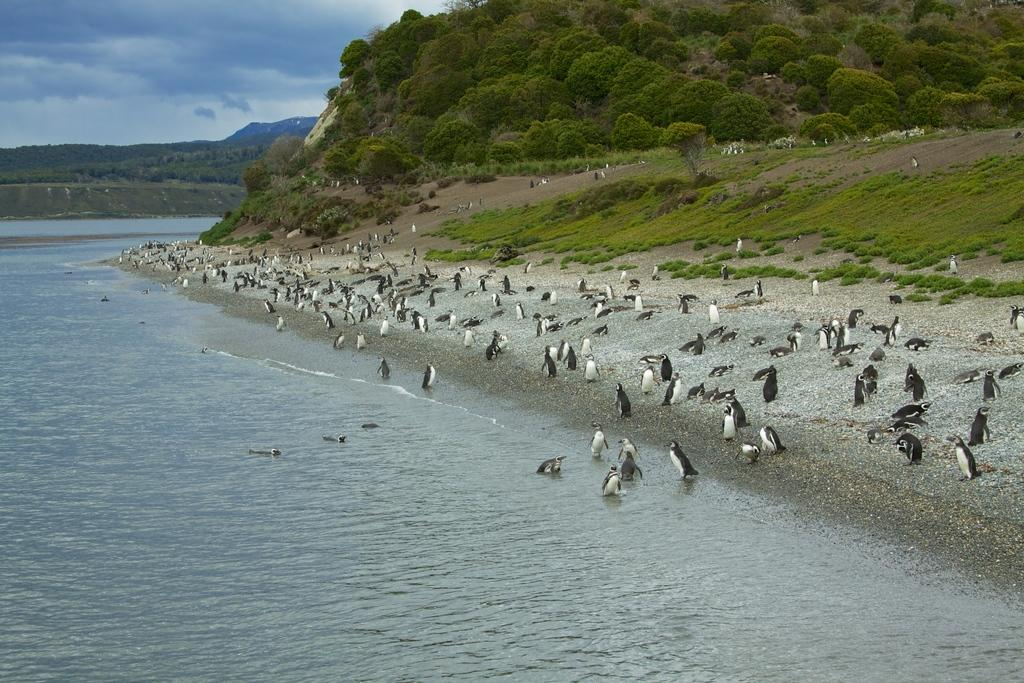What is located on the left side of the image? There is a water body on the left side of the image. What can be seen on the right side of the image? There are many penguins on the right side of the image. What type of vegetation is visible in the background of the image? There are trees in the background of the image. How would you describe the sky in the image? The sky is cloudy in the image. What type of behavior can be observed in the penguins in the image? There is no specific behavior observed in the penguins in the image; they are simply standing or sitting. What is the fire used for in the image? There is no fire present in the image. 